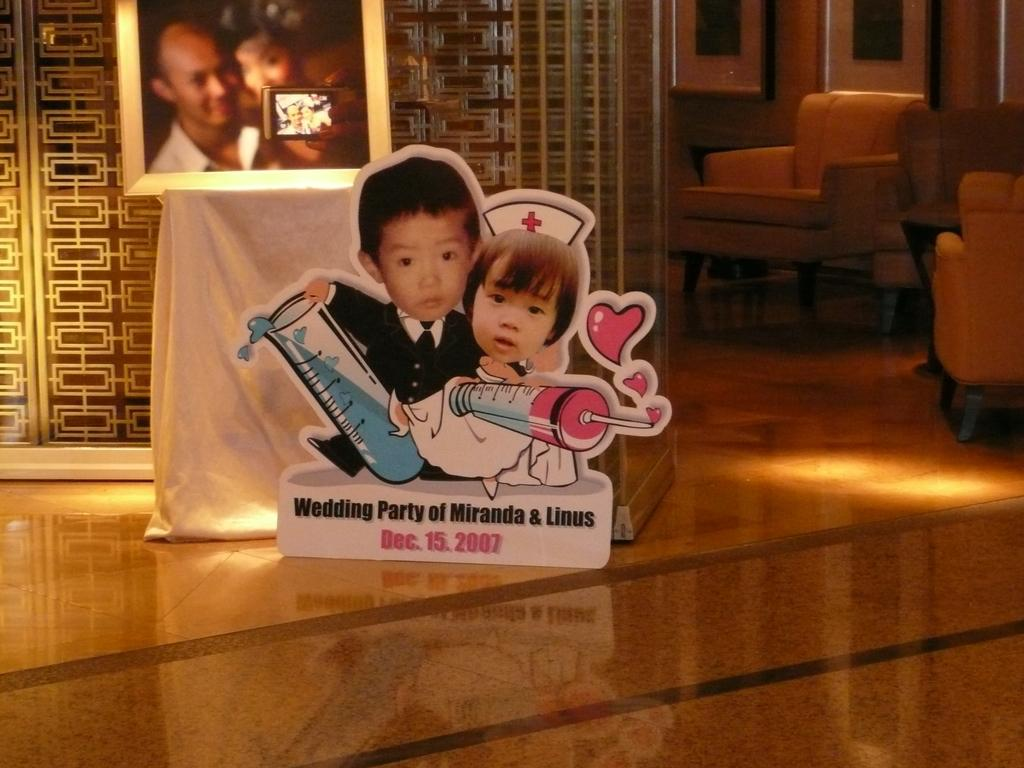What is the main object in the center of the image? There is a board in the center of the image. What can be seen on the board? There is text on the board. What can be seen in the background of the image? There is a photo frame, a wall, and chairs in the background of the image. What is visible at the bottom of the image? There is a floor visible at the bottom of the image. How many mittens are hanging on the wall in the image? There are no mittens present in the image; only a board, text, photo frame, wall, chairs, and floor are visible. What type of flight is depicted in the photo frame in the image? There is no flight depicted in the photo frame in the image; it is a separate object from the board and text. 